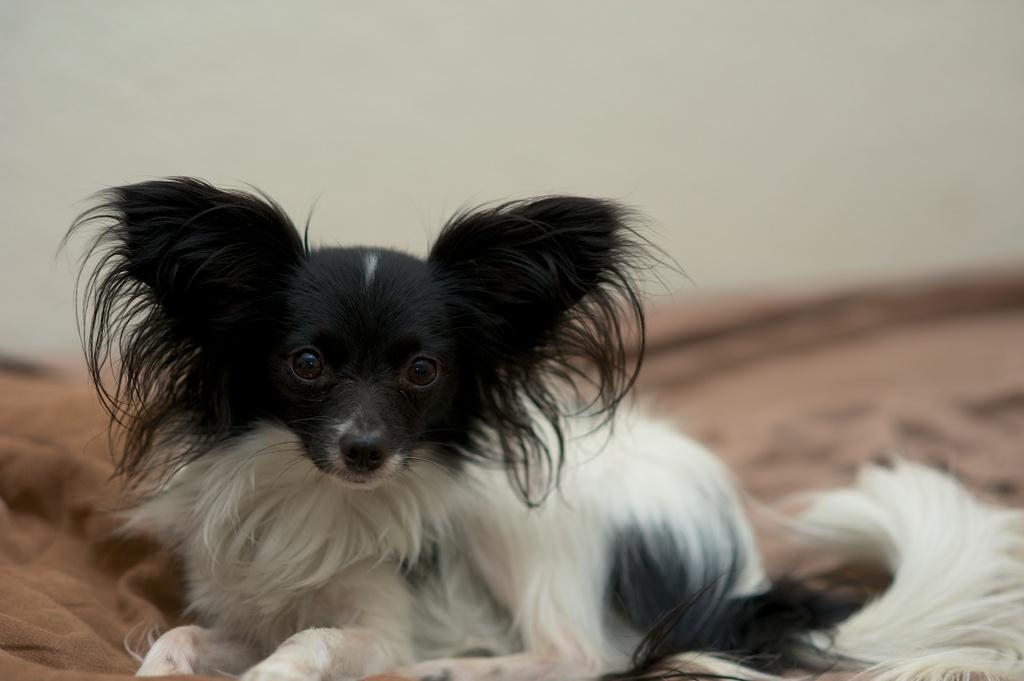In one or two sentences, can you explain what this image depicts? In this picture I can see a dog sitting on the cloth, and there is blur background. 